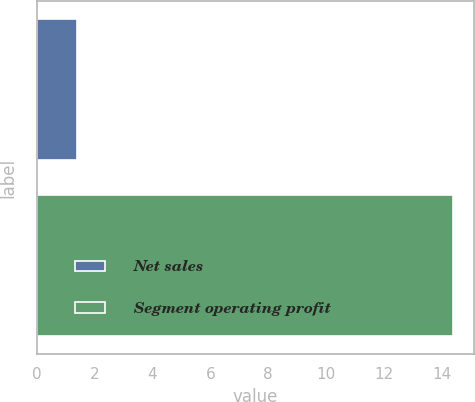Convert chart to OTSL. <chart><loc_0><loc_0><loc_500><loc_500><bar_chart><fcel>Net sales<fcel>Segment operating profit<nl><fcel>1.4<fcel>14.4<nl></chart> 